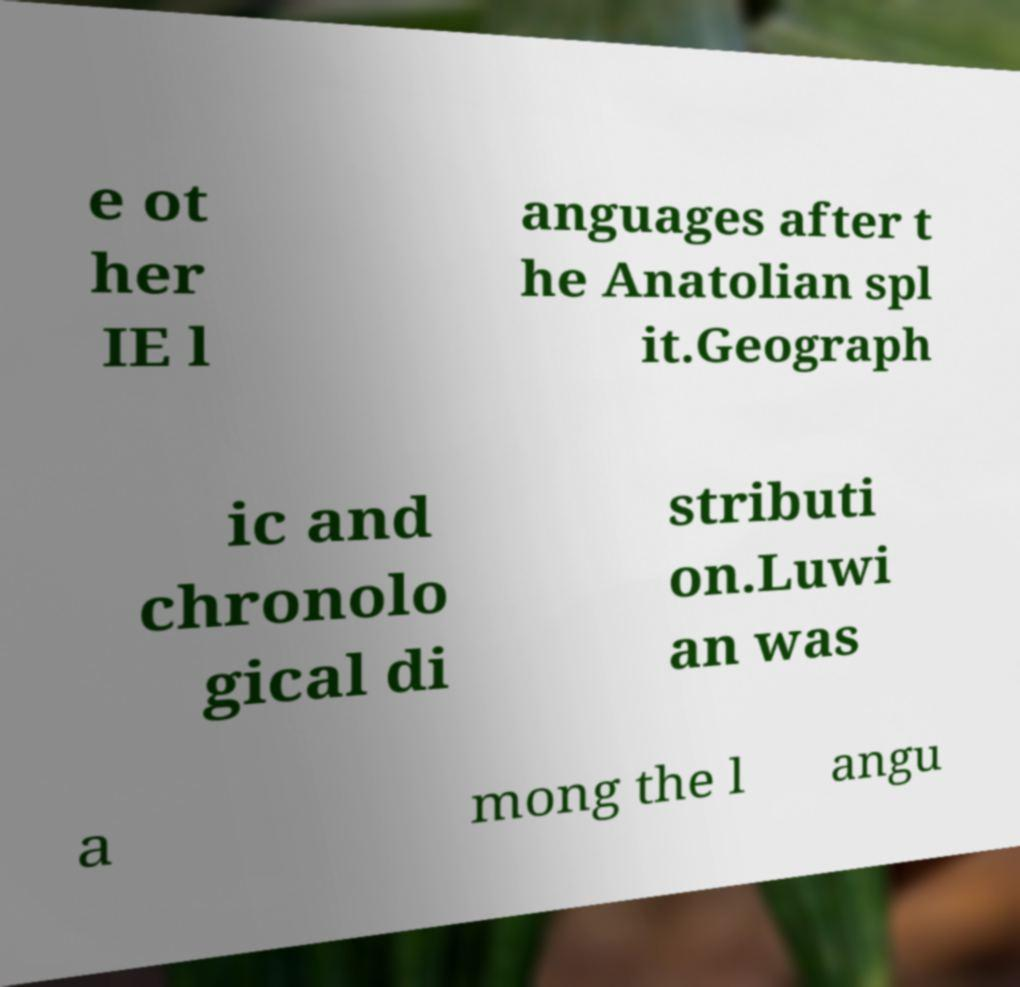Please identify and transcribe the text found in this image. e ot her IE l anguages after t he Anatolian spl it.Geograph ic and chronolo gical di stributi on.Luwi an was a mong the l angu 